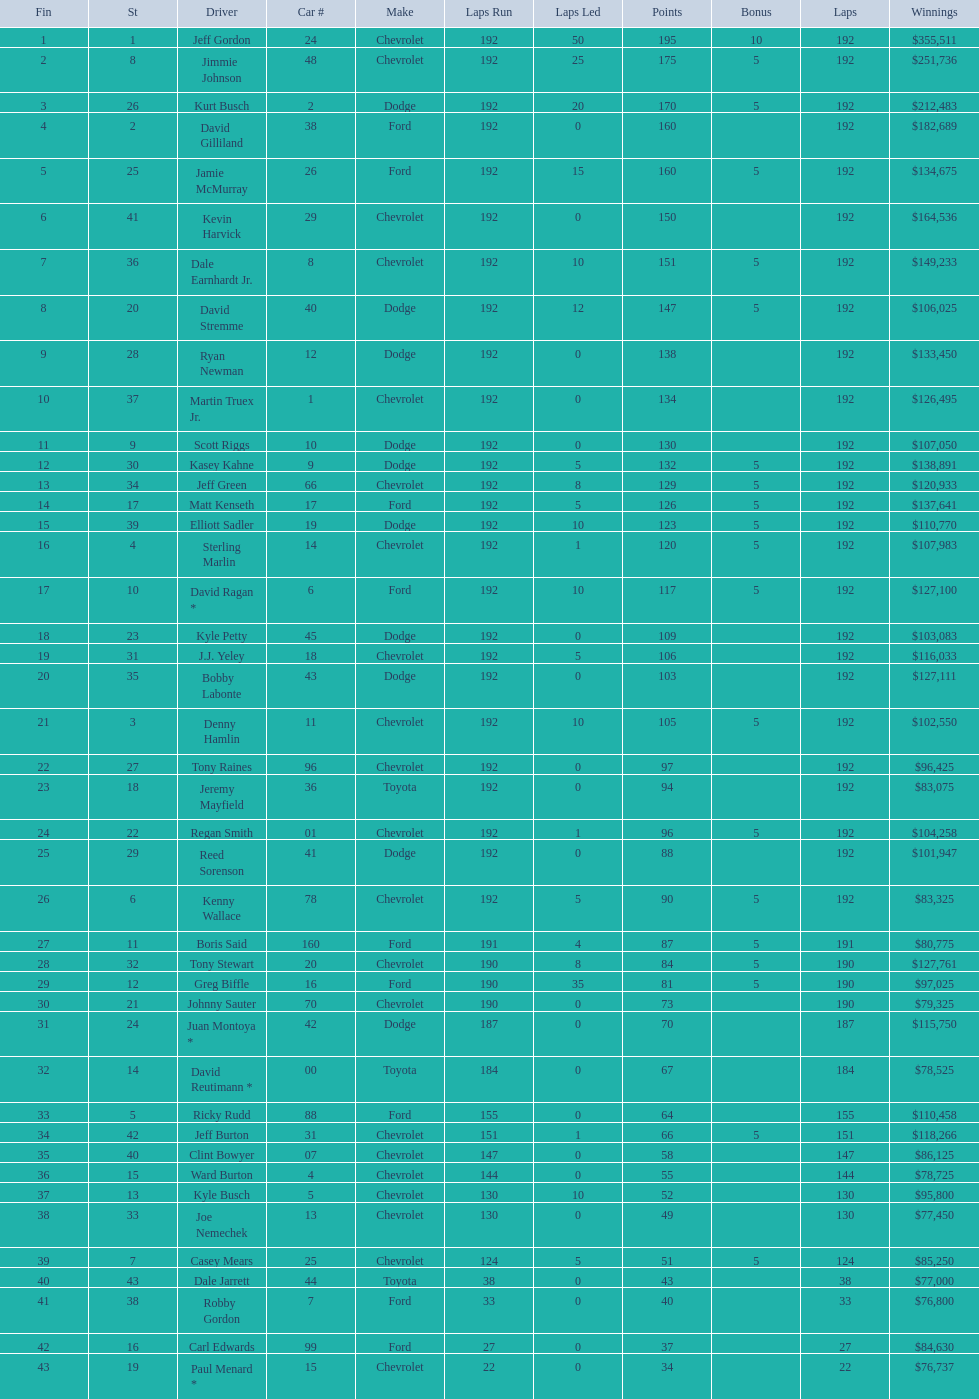How many drivers earned no bonus for this race? 23. 